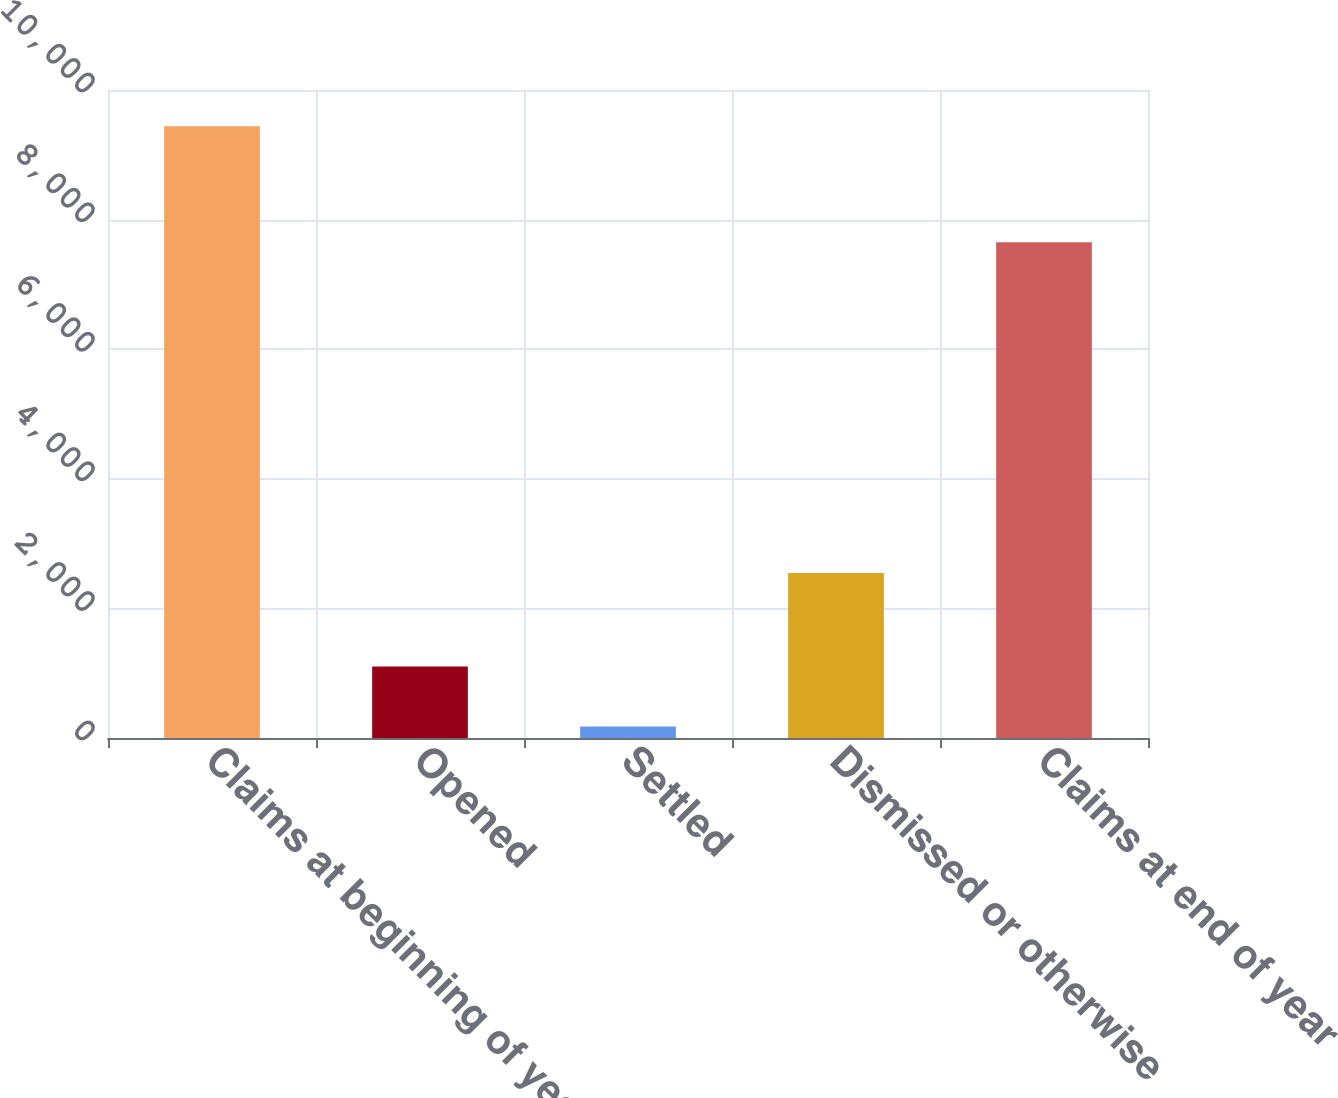<chart> <loc_0><loc_0><loc_500><loc_500><bar_chart><fcel>Claims at beginning of year<fcel>Opened<fcel>Settled<fcel>Dismissed or otherwise<fcel>Claims at end of year<nl><fcel>9442<fcel>1105.3<fcel>179<fcel>2548<fcel>7652<nl></chart> 